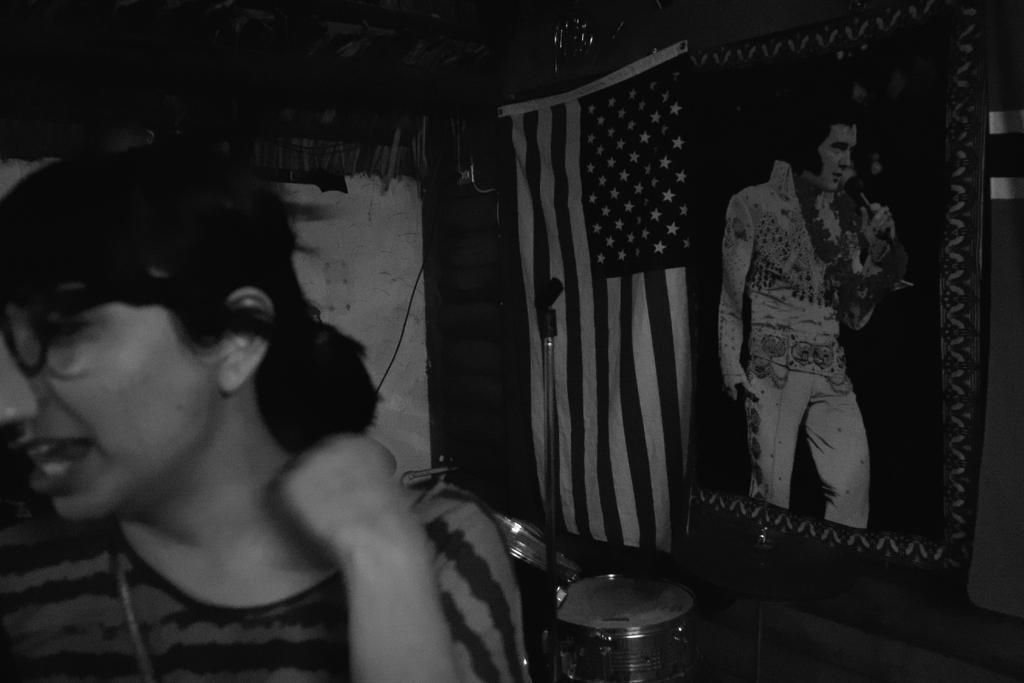Please provide a concise description of this image. This is a black and white picture. On the left side of the image we can see a person. In the background we can see musical instruments, wall, flag, and a poster. On the poster we can see picture of a person. 